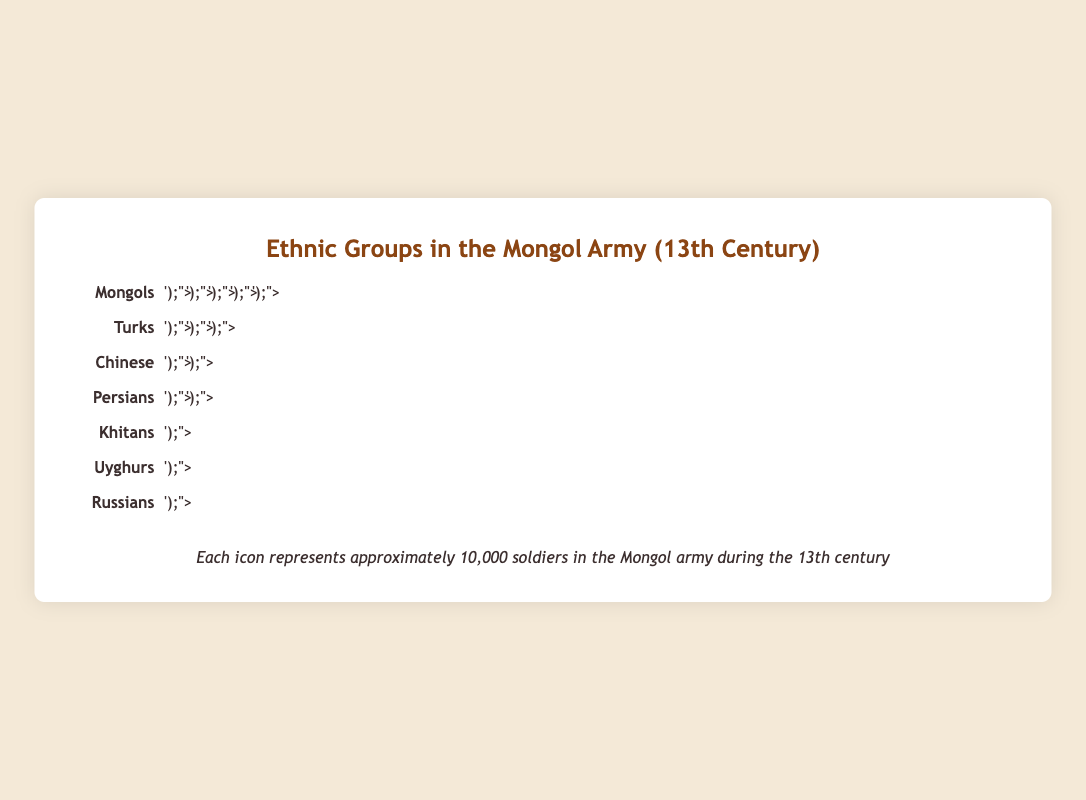What is the total number of Mongol soldiers represented in the plot? Each icon represents 10,000 soldiers, and there are 5 icons for Mongols. Therefore, 5 icons * 10,000 soldiers = 50,000 Mongol soldiers.
Answer: 50,000 How many ethnic groups are represented in the Mongol army according to the plot? Count the distinct ethnic group labels in the plot. They are Mongols, Turks, Chinese, Persians, Khitans, Uyghurs, and Russians.
Answer: 7 Which ethnic group has the second largest number of soldiers in the Mongol army? The ethnic group with the second largest number of soldiers is just after the largest. Mongols have the largest (5 icons), and Turks have the second largest (3 icons).
Answer: Turks How many more soldiers do the Mongols have compared to the Persians? Mongols have 5 icons (50,000 soldiers), and Persians have 1.5 icons (15,000 soldiers). The difference is 50,000 - 15,000.
Answer: 35,000 What percentage of the soldiers in the plot are Chinese? To find the percentage, divide the number of Chinese soldiers (20,000) by the total number of soldiers (138,000) and multiply by 100. (2 icons * 10,000 soldiers/icon) / (13.8 icons * 10,000 soldiers/icon) * 100.
Answer: ~14.49% Out of the ethnic groups with less than 10,000 soldiers, how many are there? Identify groups with less than 1 icon; Uyghurs (0.8 icons = 8,000 soldiers) and Russians (0.5 icons = 5,000 soldiers) fall in this category.
Answer: 2 If the number of soldiers from the Uyghurs doubled, how many icons would represent them? The current Uyghur representation is 0.8 icons (8,000 soldiers). Doubling this amount gives 1.6 icons (16,000 soldiers), thus 1.6 icons required.
Answer: 1.6 How does the representation of Khitans compare to that of Chinese in terms of icons used? Khitans are represented by 1 icon, and Chinese by 2 icons. The Chinese have twice as many icons as Khitans.
Answer: Twice as many If you combine the soldiers from Turks, Chinese, and Persians, what percentage of the total Mongol army do they represent? Sum the soldiers from these groups: Turks 30,000 + Chinese 20,000 + Persians 15,000 = 65,000. Calculate the percentage: 65,000 / 138,000 * 100
Answer: ~47.10% Which ethnic groups have fewer than 20,000 soldiers in the Mongol army? Determine the groups with less than 2 icons: Persians, Khitans, Uyghurs, and Russians match this criterion.
Answer: Persians, Khitans, Uyghurs, Russians 